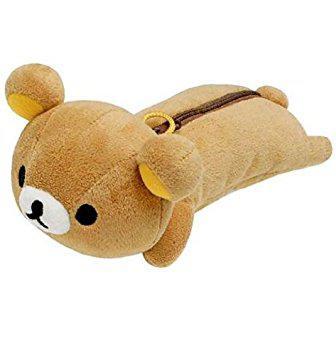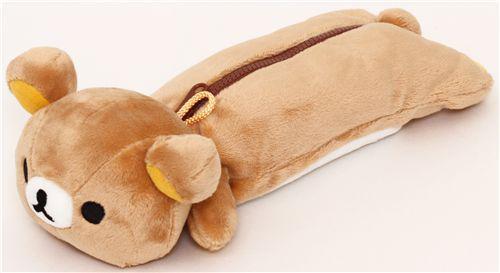The first image is the image on the left, the second image is the image on the right. Analyze the images presented: Is the assertion "a pencil pouch has a strawberry on the zipper" valid? Answer yes or no. No. The first image is the image on the left, the second image is the image on the right. Examine the images to the left and right. Is the description "There is a plush teddy bear pencil case with a zipper facing to the left in both of the images." accurate? Answer yes or no. Yes. 